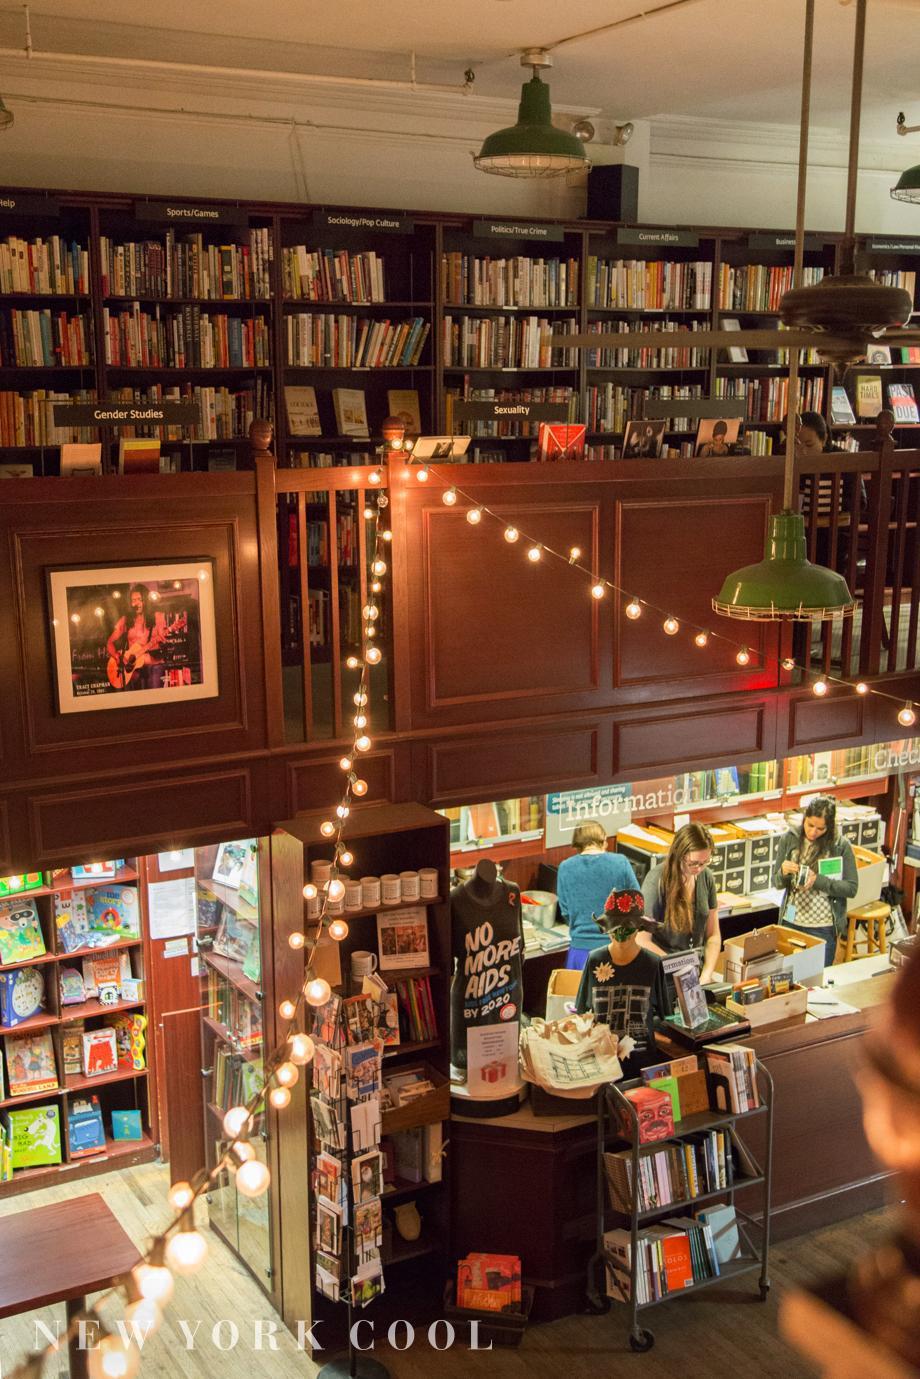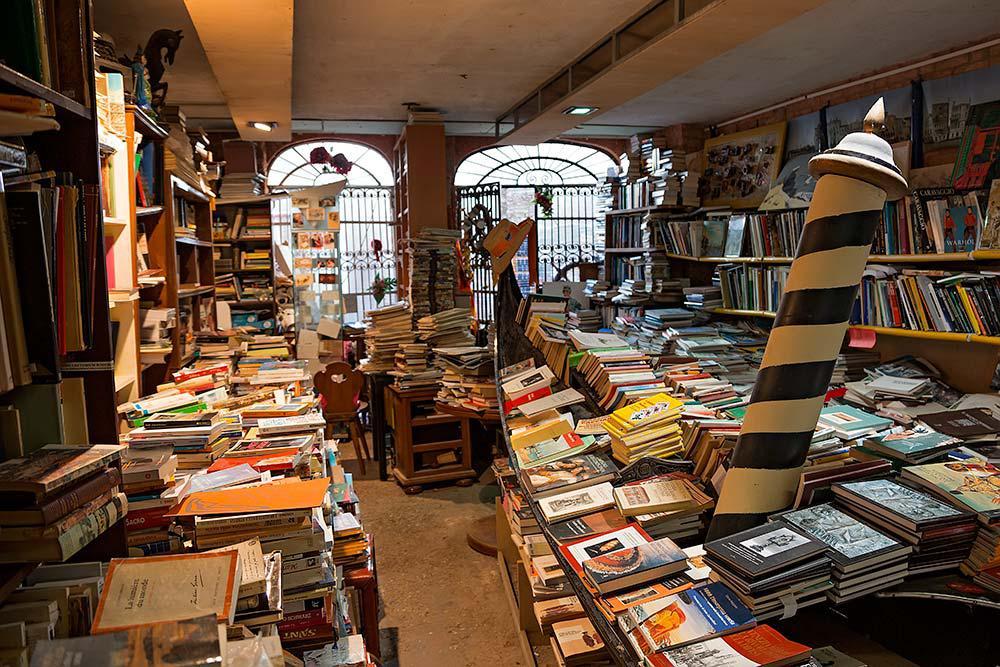The first image is the image on the left, the second image is the image on the right. For the images shown, is this caption "There is a stairway visible in one of the images." true? Answer yes or no. No. 